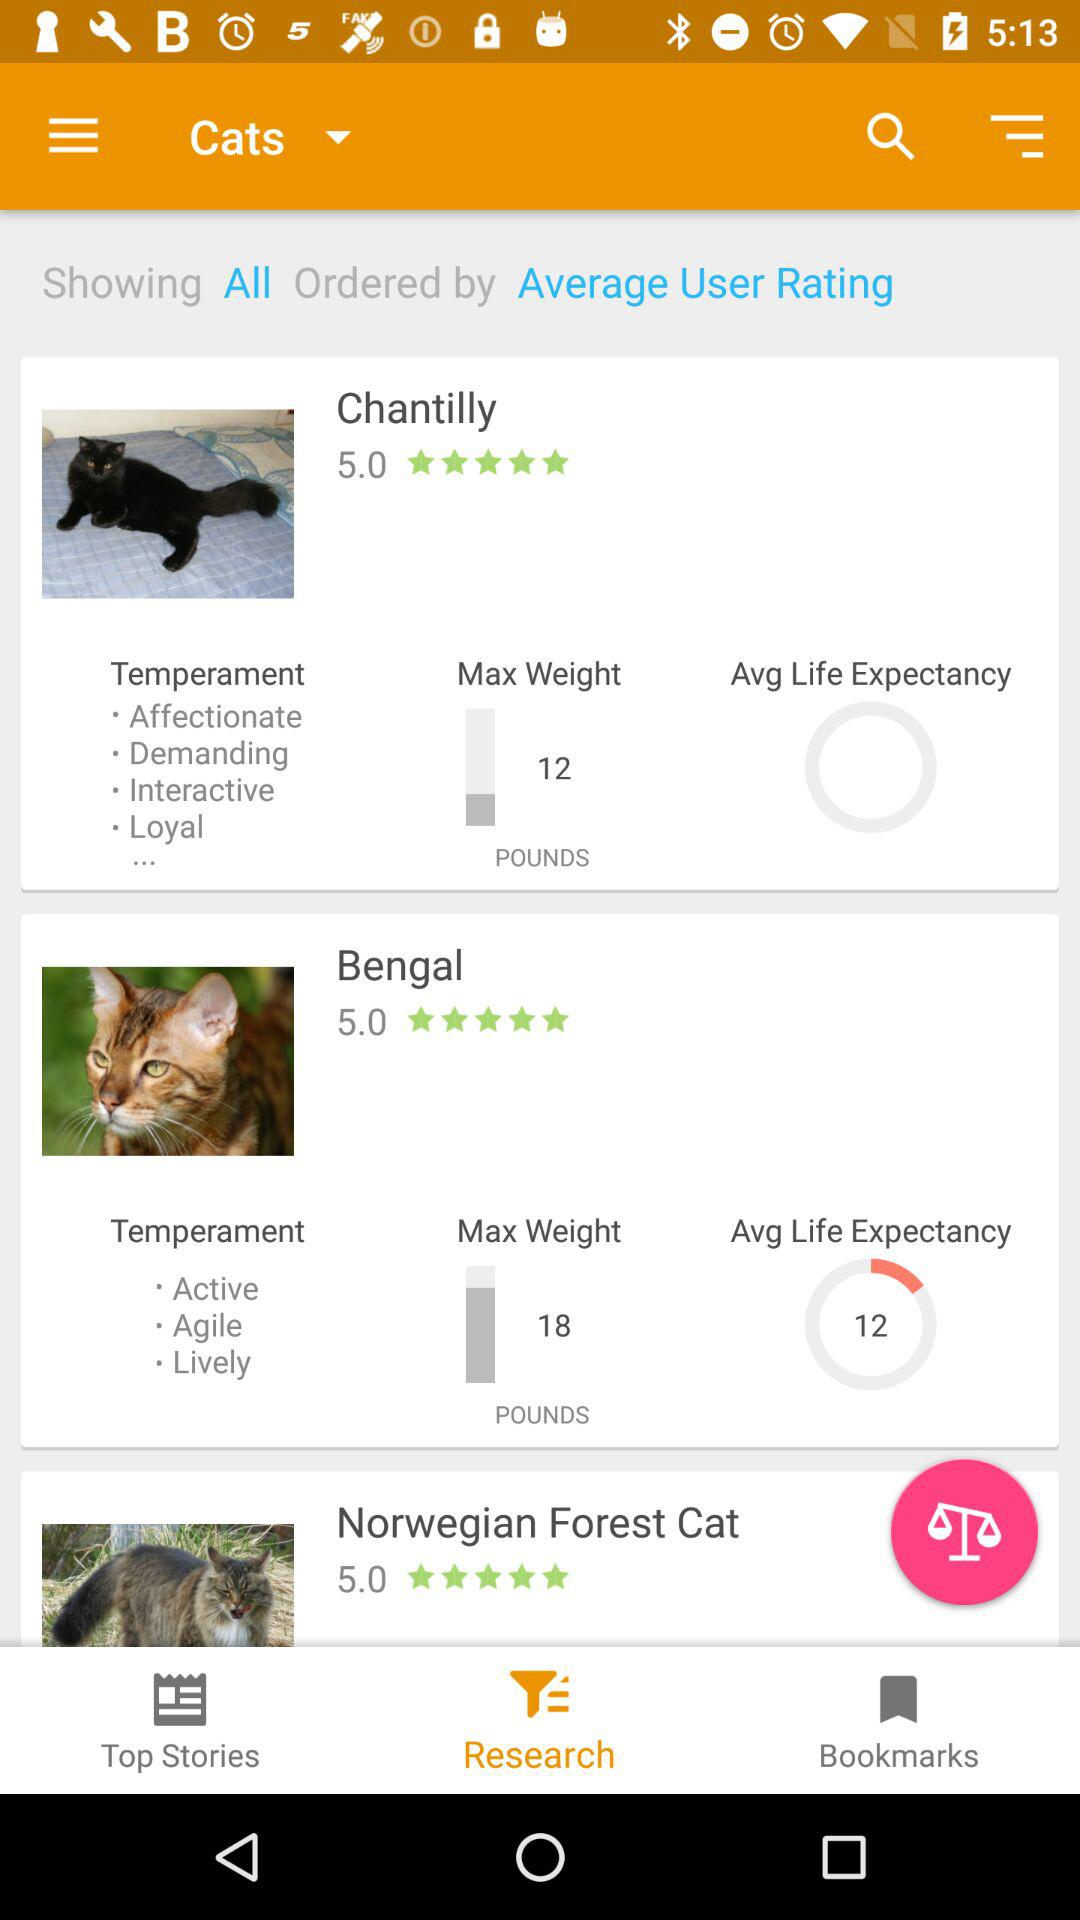How much does the Norwegian forest cat weigh?
When the provided information is insufficient, respond with <no answer>. <no answer> 